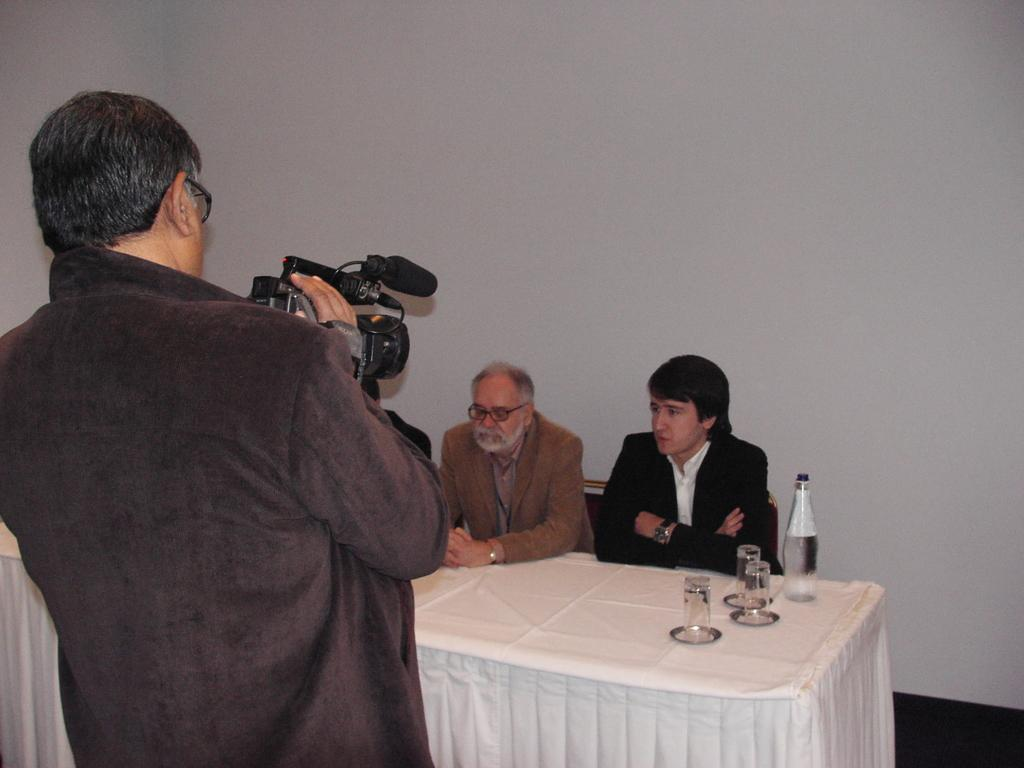How many people are sitting in the image? There are two persons sitting on chairs in the image. What is the person in the background doing? The person in the background is standing and holding a camera. What objects can be seen on the table? There are glasses and a bottle on the table. What is visible in the background of the image? There is a wall in the background. What type of milk is being served in the image? There is no milk present in the image. What is the plot of the story unfolding in the image? The image does not depict a story or plot; it is a static scene with people and objects. Did an earthquake occur in the image? There is no indication of an earthquake or any natural disaster in the image. 